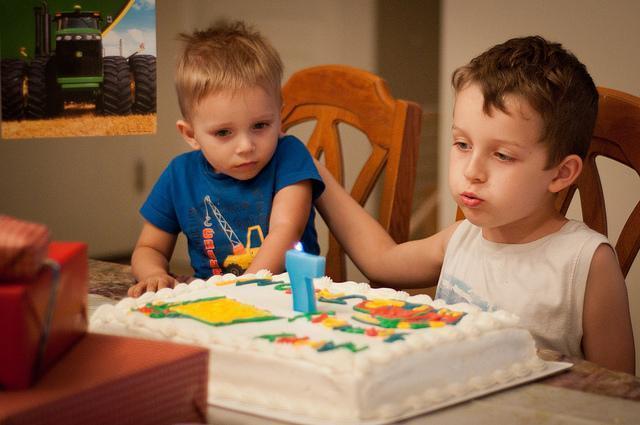How many years is the child turning?
Give a very brief answer. 7. How many cakes are on the table?
Give a very brief answer. 1. How many trucks are in the photo?
Give a very brief answer. 1. How many chairs are there?
Give a very brief answer. 2. How many people can be seen?
Give a very brief answer. 2. 